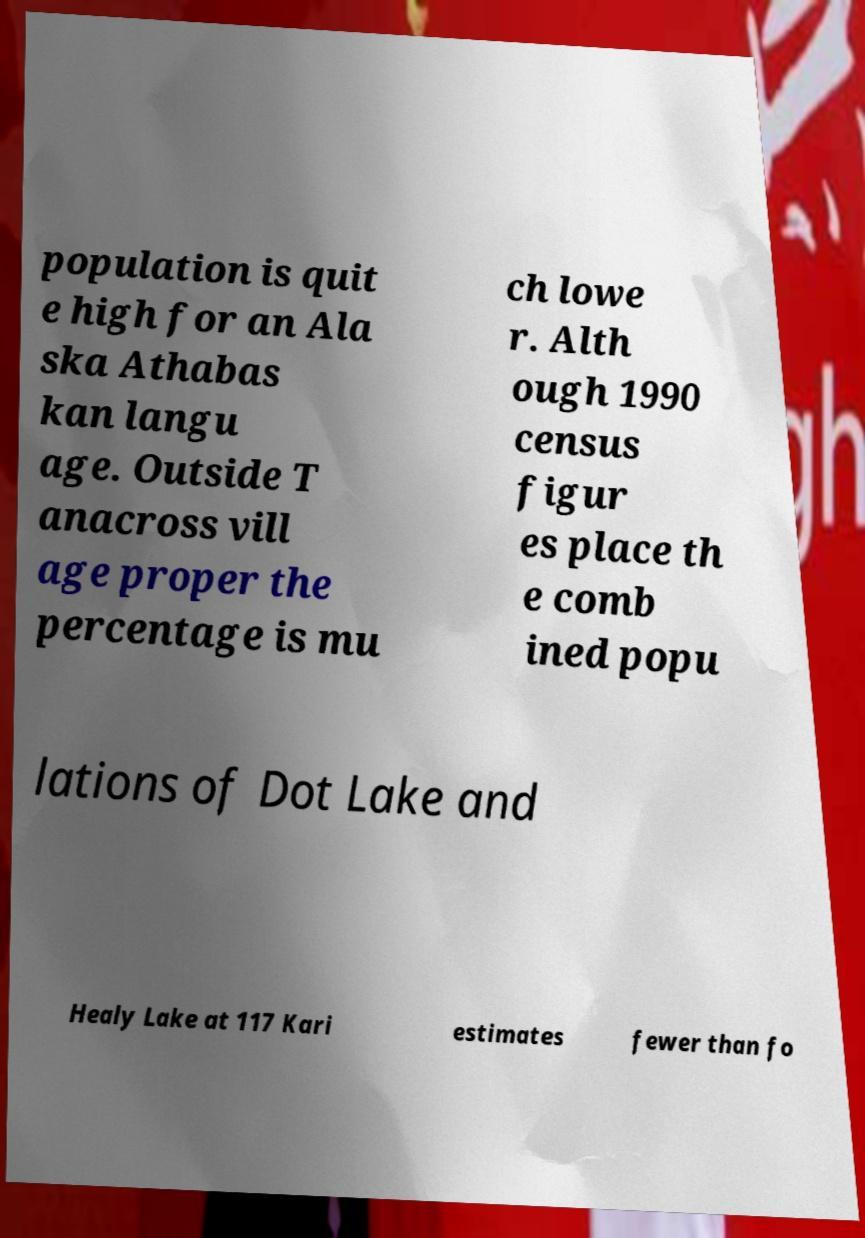Could you assist in decoding the text presented in this image and type it out clearly? population is quit e high for an Ala ska Athabas kan langu age. Outside T anacross vill age proper the percentage is mu ch lowe r. Alth ough 1990 census figur es place th e comb ined popu lations of Dot Lake and Healy Lake at 117 Kari estimates fewer than fo 